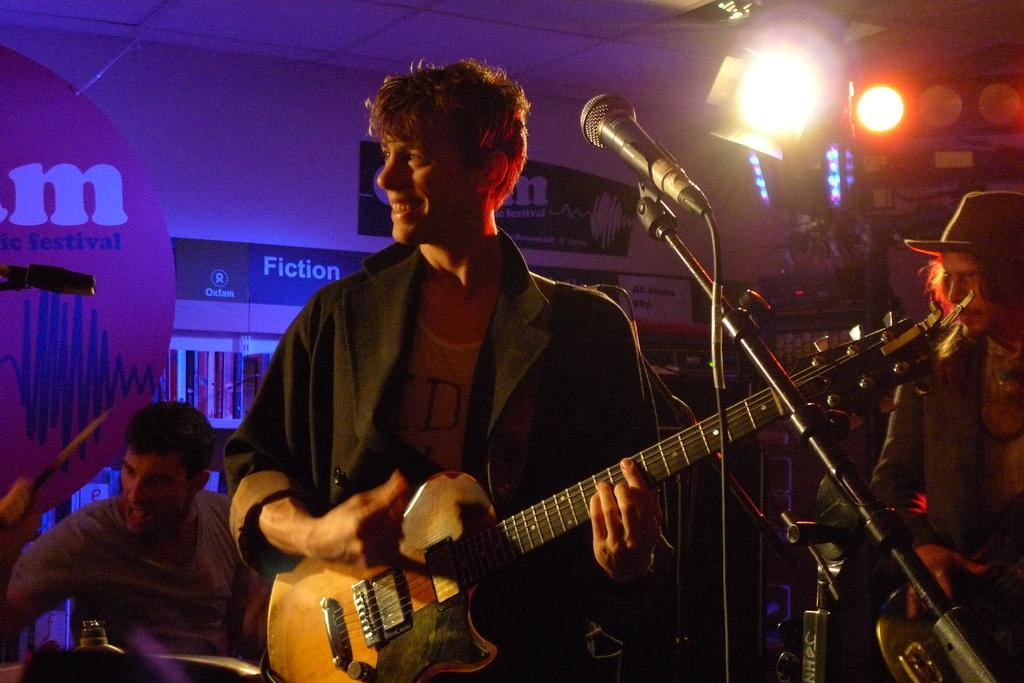How would you summarize this image in a sentence or two? In this image I can see few people where one man is holding a guitar. I can also see a smile on his face. Here I can see a mic. 